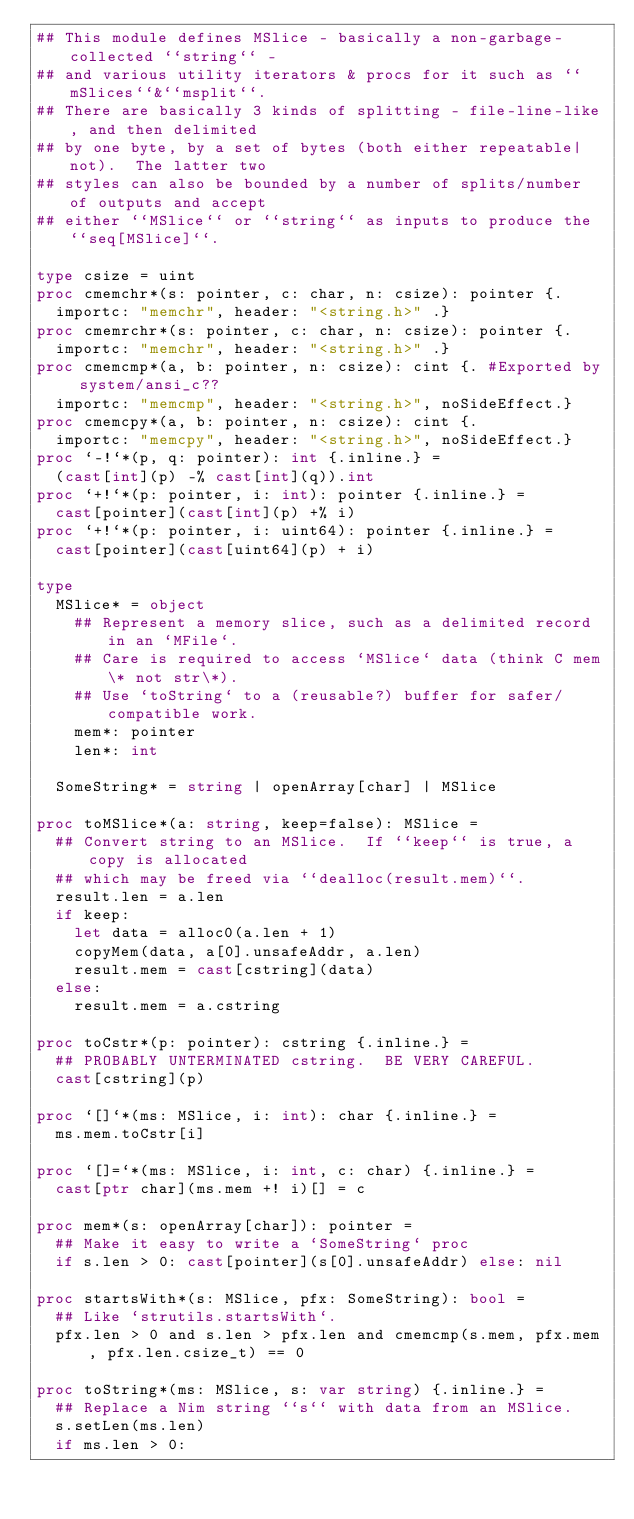Convert code to text. <code><loc_0><loc_0><loc_500><loc_500><_Nim_>## This module defines MSlice - basically a non-garbage-collected ``string`` -
## and various utility iterators & procs for it such as ``mSlices``&``msplit``.
## There are basically 3 kinds of splitting - file-line-like, and then delimited
## by one byte, by a set of bytes (both either repeatable|not).  The latter two
## styles can also be bounded by a number of splits/number of outputs and accept
## either ``MSlice`` or ``string`` as inputs to produce the ``seq[MSlice]``.

type csize = uint
proc cmemchr*(s: pointer, c: char, n: csize): pointer {.
  importc: "memchr", header: "<string.h>" .}
proc cmemrchr*(s: pointer, c: char, n: csize): pointer {.
  importc: "memchr", header: "<string.h>" .}
proc cmemcmp*(a, b: pointer, n: csize): cint {. #Exported by system/ansi_c??
  importc: "memcmp", header: "<string.h>", noSideEffect.}
proc cmemcpy*(a, b: pointer, n: csize): cint {.
  importc: "memcpy", header: "<string.h>", noSideEffect.}
proc `-!`*(p, q: pointer): int {.inline.} =
  (cast[int](p) -% cast[int](q)).int
proc `+!`*(p: pointer, i: int): pointer {.inline.} =
  cast[pointer](cast[int](p) +% i)
proc `+!`*(p: pointer, i: uint64): pointer {.inline.} =
  cast[pointer](cast[uint64](p) + i)

type
  MSlice* = object
    ## Represent a memory slice, such as a delimited record in an `MFile`.
    ## Care is required to access `MSlice` data (think C mem\* not str\*).
    ## Use `toString` to a (reusable?) buffer for safer/compatible work.
    mem*: pointer
    len*: int

  SomeString* = string | openArray[char] | MSlice

proc toMSlice*(a: string, keep=false): MSlice =
  ## Convert string to an MSlice.  If ``keep`` is true, a copy is allocated
  ## which may be freed via ``dealloc(result.mem)``.
  result.len = a.len
  if keep:
    let data = alloc0(a.len + 1)
    copyMem(data, a[0].unsafeAddr, a.len)
    result.mem = cast[cstring](data)
  else:
    result.mem = a.cstring

proc toCstr*(p: pointer): cstring {.inline.} =
  ## PROBABLY UNTERMINATED cstring.  BE VERY CAREFUL.
  cast[cstring](p)

proc `[]`*(ms: MSlice, i: int): char {.inline.} =
  ms.mem.toCstr[i]

proc `[]=`*(ms: MSlice, i: int, c: char) {.inline.} =
  cast[ptr char](ms.mem +! i)[] = c

proc mem*(s: openArray[char]): pointer =
  ## Make it easy to write a `SomeString` proc
  if s.len > 0: cast[pointer](s[0].unsafeAddr) else: nil

proc startsWith*(s: MSlice, pfx: SomeString): bool =
  ## Like `strutils.startsWith`.
  pfx.len > 0 and s.len > pfx.len and cmemcmp(s.mem, pfx.mem, pfx.len.csize_t) == 0

proc toString*(ms: MSlice, s: var string) {.inline.} =
  ## Replace a Nim string ``s`` with data from an MSlice.
  s.setLen(ms.len)
  if ms.len > 0:</code> 